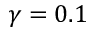<formula> <loc_0><loc_0><loc_500><loc_500>\gamma = 0 . 1</formula> 